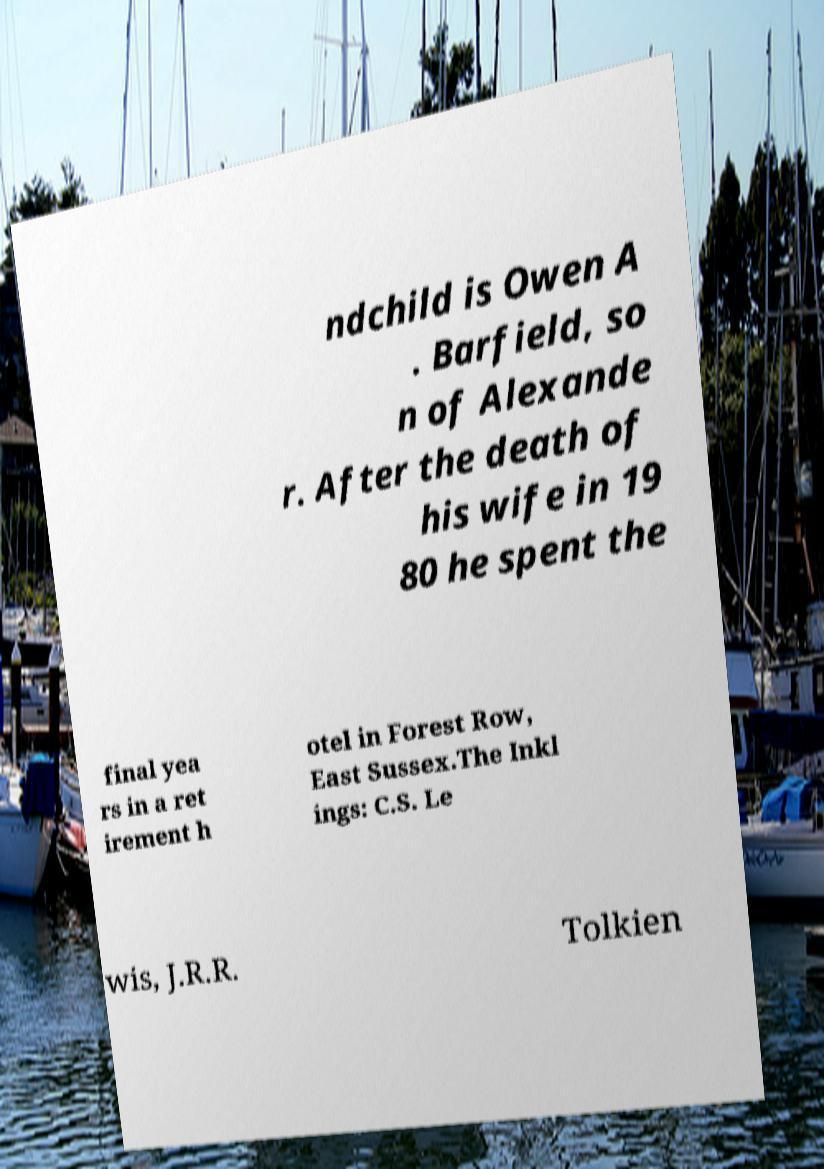Could you extract and type out the text from this image? ndchild is Owen A . Barfield, so n of Alexande r. After the death of his wife in 19 80 he spent the final yea rs in a ret irement h otel in Forest Row, East Sussex.The Inkl ings: C.S. Le wis, J.R.R. Tolkien 